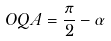Convert formula to latex. <formula><loc_0><loc_0><loc_500><loc_500>O Q A = { \frac { \pi } { 2 } } - \alpha</formula> 